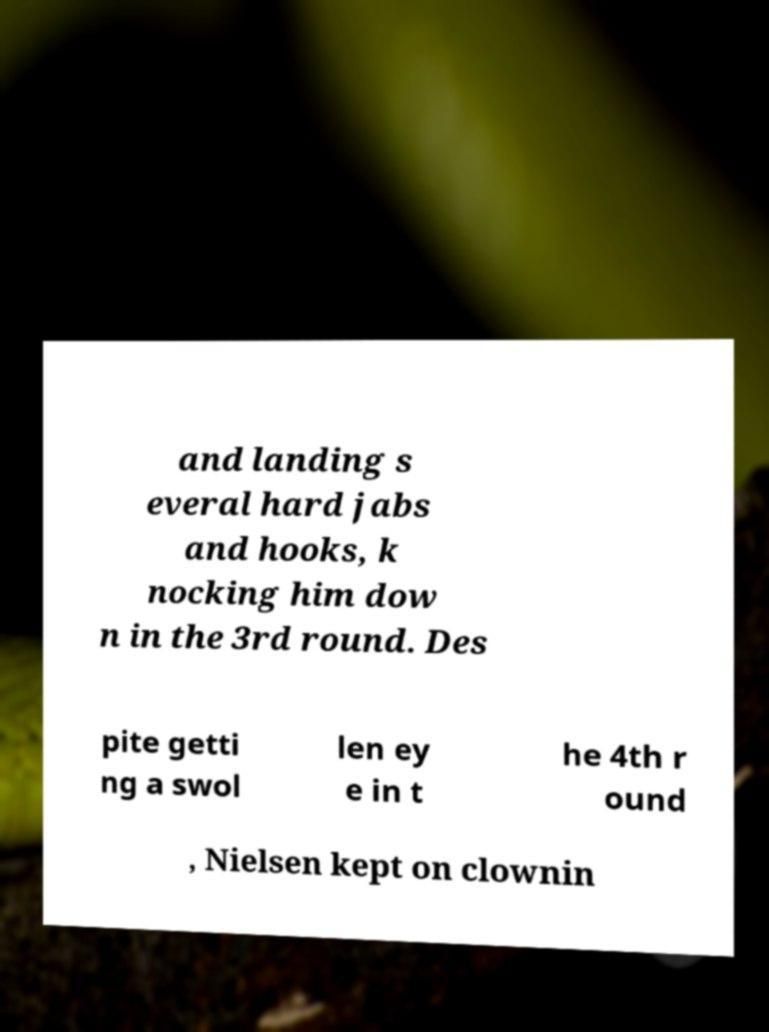I need the written content from this picture converted into text. Can you do that? and landing s everal hard jabs and hooks, k nocking him dow n in the 3rd round. Des pite getti ng a swol len ey e in t he 4th r ound , Nielsen kept on clownin 